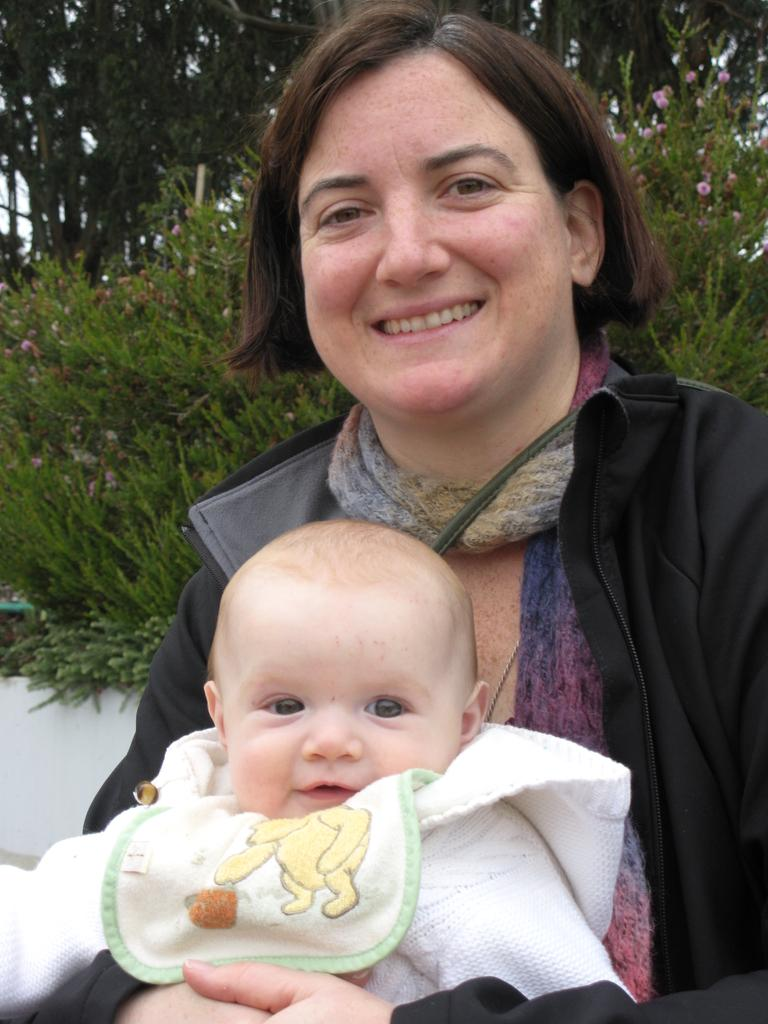Who is in the image? There is a woman in the image. What is the woman doing in the image? The woman is holding a baby. How are the woman and baby feeling in the image? The woman and baby are smiling. What can be seen in the background of the image? There are plants, trees, and a white wall in the background of the image. What type of joke is the woman telling the baby in the image? There is no indication in the image that the woman is telling a joke to the baby. 